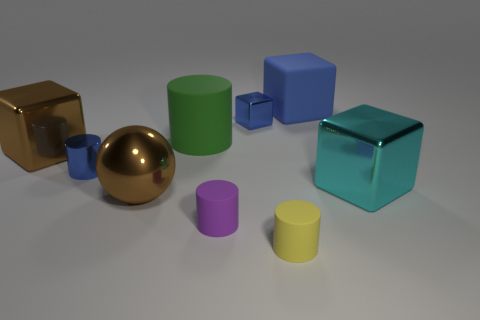Subtract all blue cylinders. How many cylinders are left? 3 Subtract all purple balls. How many blue cubes are left? 2 Subtract all brown cubes. How many cubes are left? 3 Subtract all balls. How many objects are left? 8 Subtract 2 blocks. How many blocks are left? 2 Subtract all brown blocks. Subtract all green cylinders. How many blocks are left? 3 Subtract all big brown cubes. Subtract all green cylinders. How many objects are left? 7 Add 9 small purple things. How many small purple things are left? 10 Add 7 tiny green metallic cylinders. How many tiny green metallic cylinders exist? 7 Subtract 1 yellow cylinders. How many objects are left? 8 